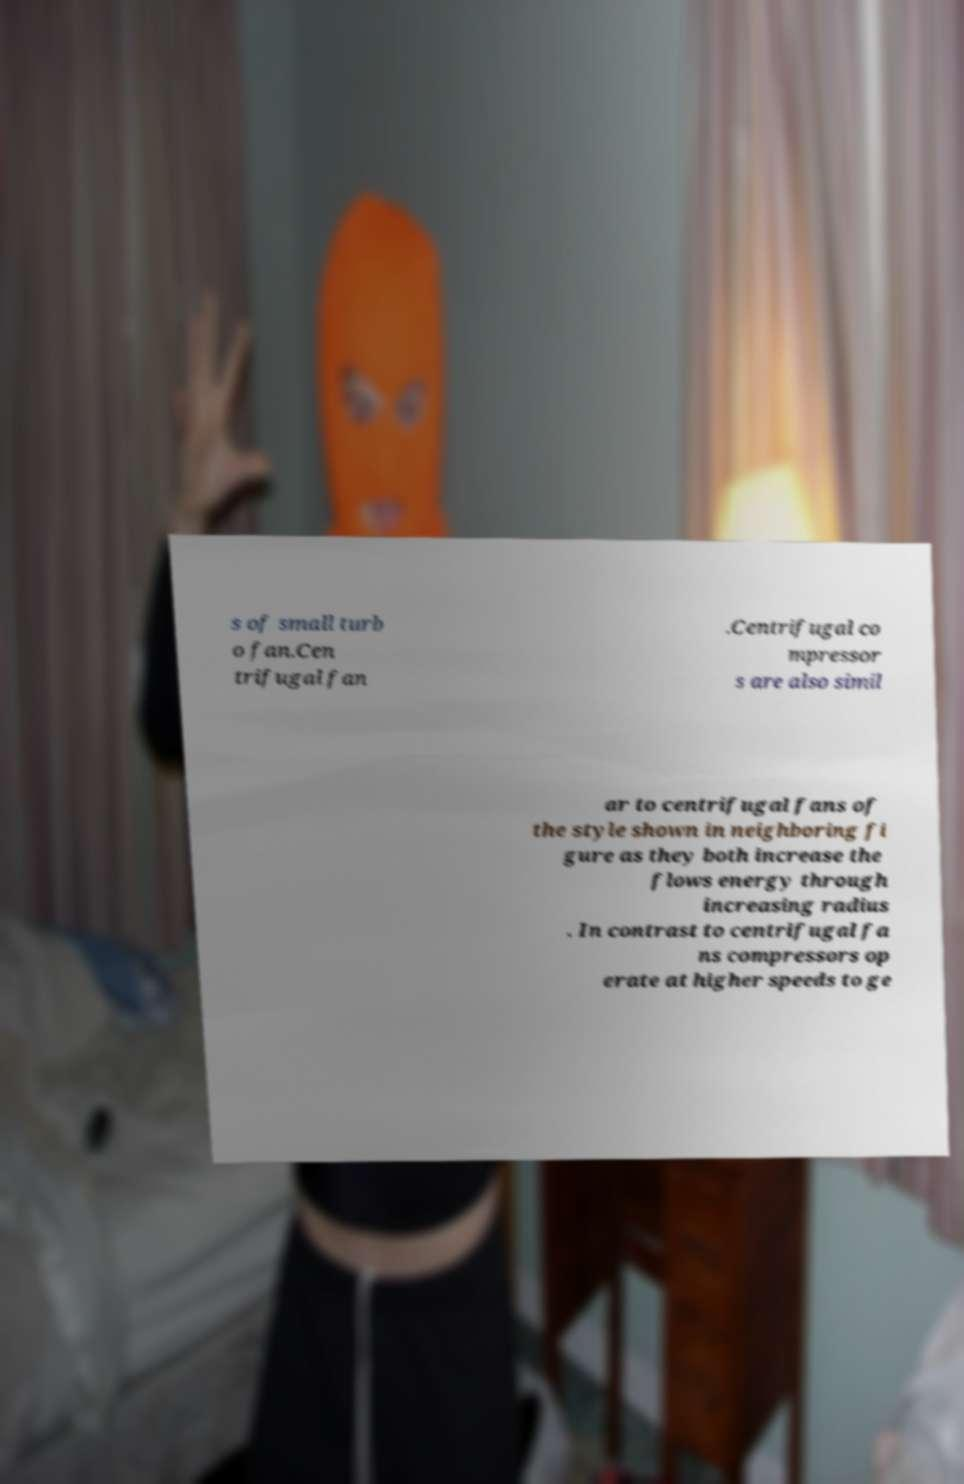Could you assist in decoding the text presented in this image and type it out clearly? s of small turb o fan.Cen trifugal fan .Centrifugal co mpressor s are also simil ar to centrifugal fans of the style shown in neighboring fi gure as they both increase the flows energy through increasing radius . In contrast to centrifugal fa ns compressors op erate at higher speeds to ge 